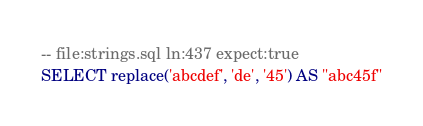<code> <loc_0><loc_0><loc_500><loc_500><_SQL_>-- file:strings.sql ln:437 expect:true
SELECT replace('abcdef', 'de', '45') AS "abc45f"
</code> 